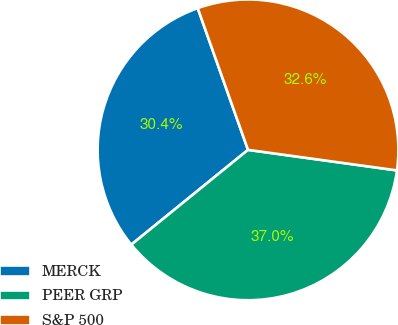Convert chart. <chart><loc_0><loc_0><loc_500><loc_500><pie_chart><fcel>MERCK<fcel>PEER GRP<fcel>S&P 500<nl><fcel>30.43%<fcel>36.96%<fcel>32.61%<nl></chart> 